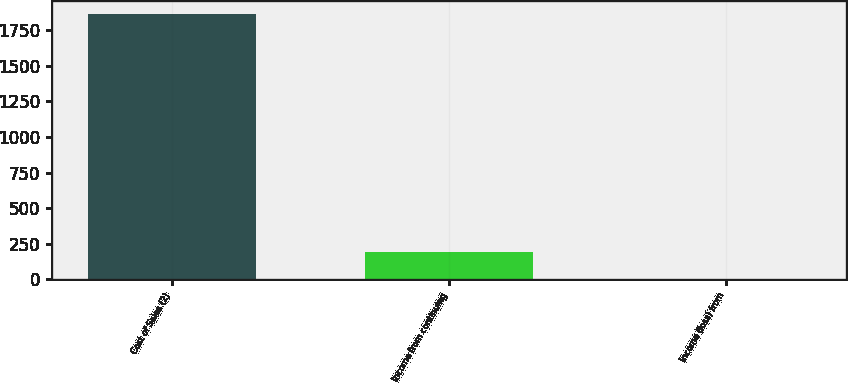<chart> <loc_0><loc_0><loc_500><loc_500><bar_chart><fcel>Cost of Sales (2)<fcel>Income from continuing<fcel>Income (loss) from<nl><fcel>1863<fcel>192<fcel>2<nl></chart> 